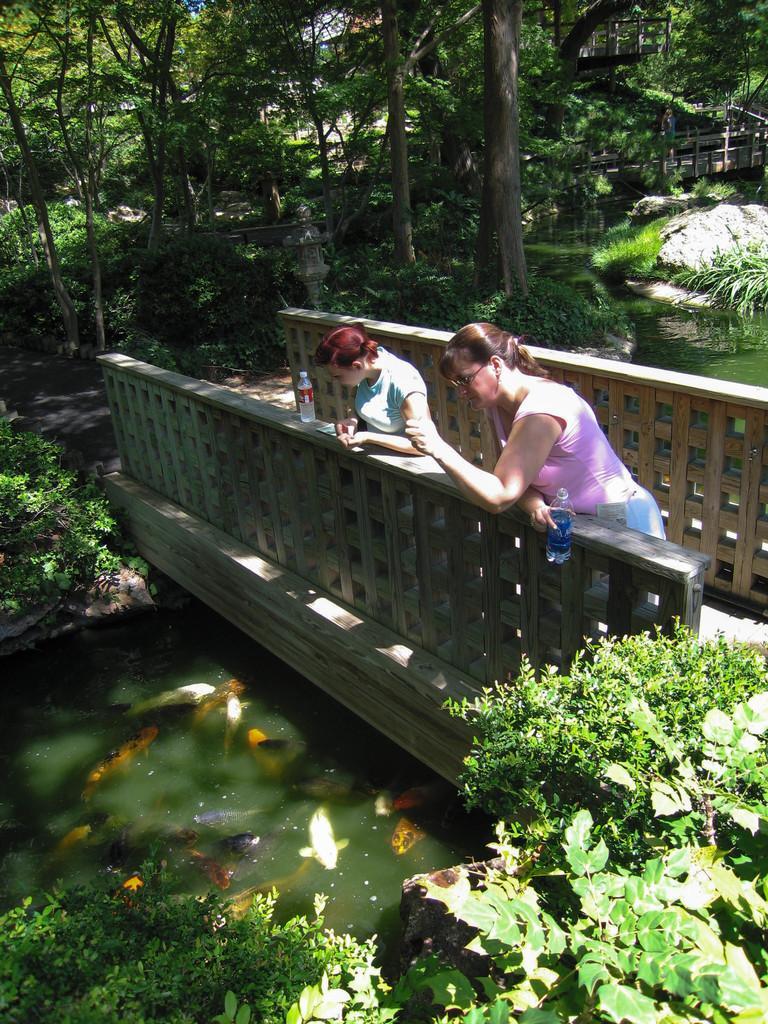Describe this image in one or two sentences. In the center of the image we can see a bridge with fences. On the bridge, we can see one water bottle and two persons are standing. Among them, we can see one person is holding a bottle. Below the bridge, we can see water. In the water, we can see the fish. At the bottom of the image, we can see plants. In the background, we can see trees, rocks, water, plants, grass and a wooden bridge. 